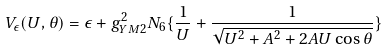Convert formula to latex. <formula><loc_0><loc_0><loc_500><loc_500>V _ { \epsilon } ( U , \theta ) = \epsilon + g _ { Y M 2 } ^ { 2 } N _ { 6 } \{ \frac { 1 } { U } + \frac { 1 } { \sqrt { U ^ { 2 } + A ^ { 2 } + 2 A U \cos \theta } } \}</formula> 